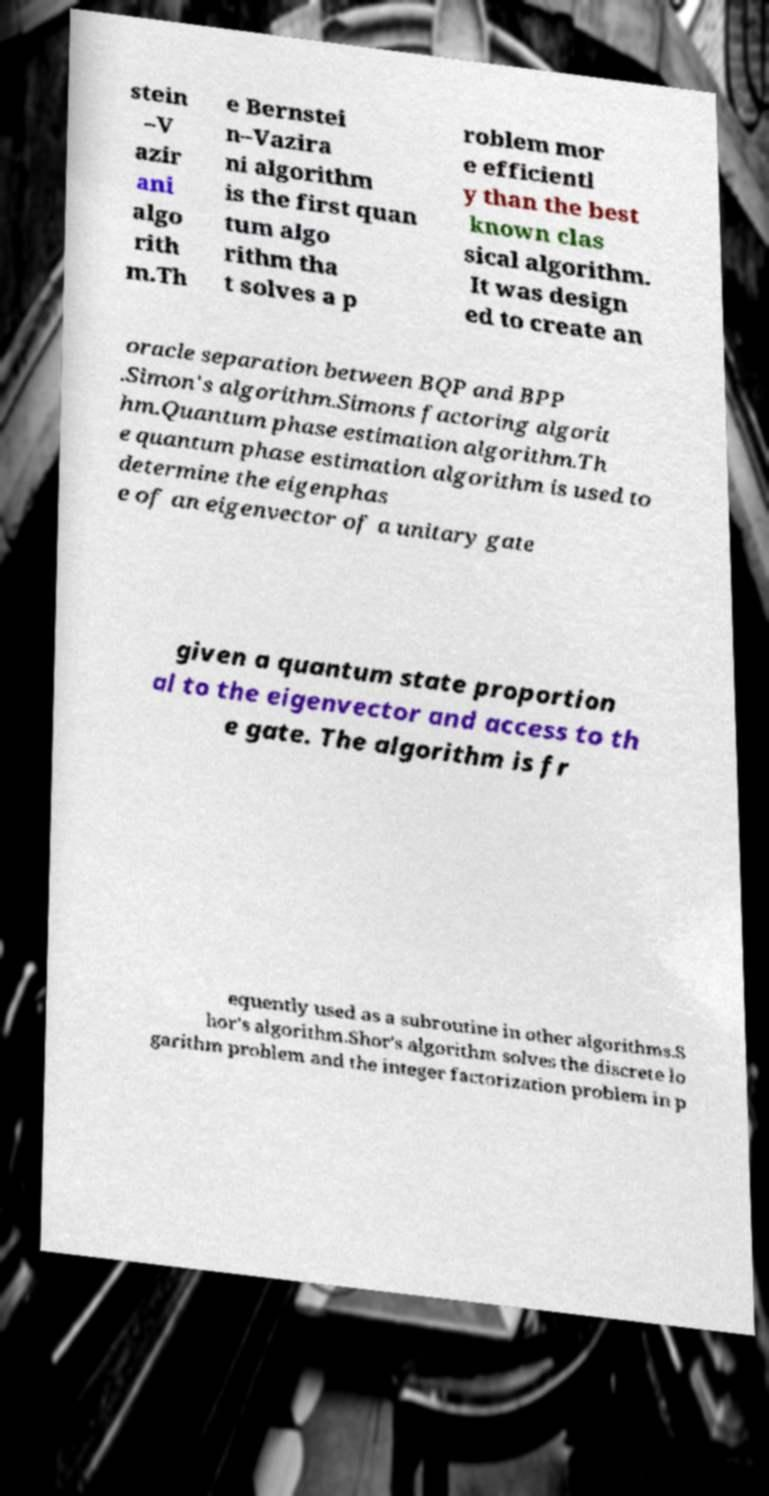Can you accurately transcribe the text from the provided image for me? stein –V azir ani algo rith m.Th e Bernstei n–Vazira ni algorithm is the first quan tum algo rithm tha t solves a p roblem mor e efficientl y than the best known clas sical algorithm. It was design ed to create an oracle separation between BQP and BPP .Simon's algorithm.Simons factoring algorit hm.Quantum phase estimation algorithm.Th e quantum phase estimation algorithm is used to determine the eigenphas e of an eigenvector of a unitary gate given a quantum state proportion al to the eigenvector and access to th e gate. The algorithm is fr equently used as a subroutine in other algorithms.S hor's algorithm.Shor's algorithm solves the discrete lo garithm problem and the integer factorization problem in p 